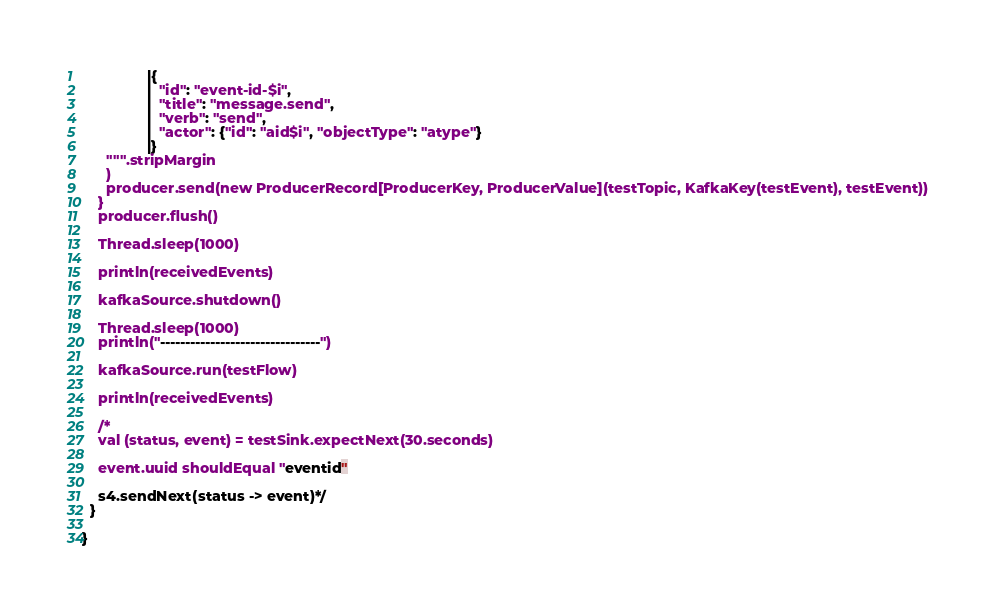Convert code to text. <code><loc_0><loc_0><loc_500><loc_500><_Scala_>                |{
                |  "id": "event-id-$i",
                |  "title": "message.send",
                |  "verb": "send",
                |  "actor": {"id": "aid$i", "objectType": "atype"}
                |}
      """.stripMargin
      )
      producer.send(new ProducerRecord[ProducerKey, ProducerValue](testTopic, KafkaKey(testEvent), testEvent))
    }
    producer.flush()

    Thread.sleep(1000)

    println(receivedEvents)

    kafkaSource.shutdown()

    Thread.sleep(1000)
    println("--------------------------------")

    kafkaSource.run(testFlow)

    println(receivedEvents)

    /*
    val (status, event) = testSink.expectNext(30.seconds)

    event.uuid shouldEqual "eventid"

    s4.sendNext(status -> event)*/
  }

}
</code> 